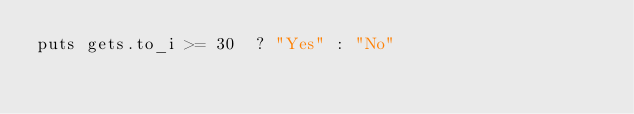Convert code to text. <code><loc_0><loc_0><loc_500><loc_500><_Ruby_>puts gets.to_i >= 30  ? "Yes" : "No"</code> 